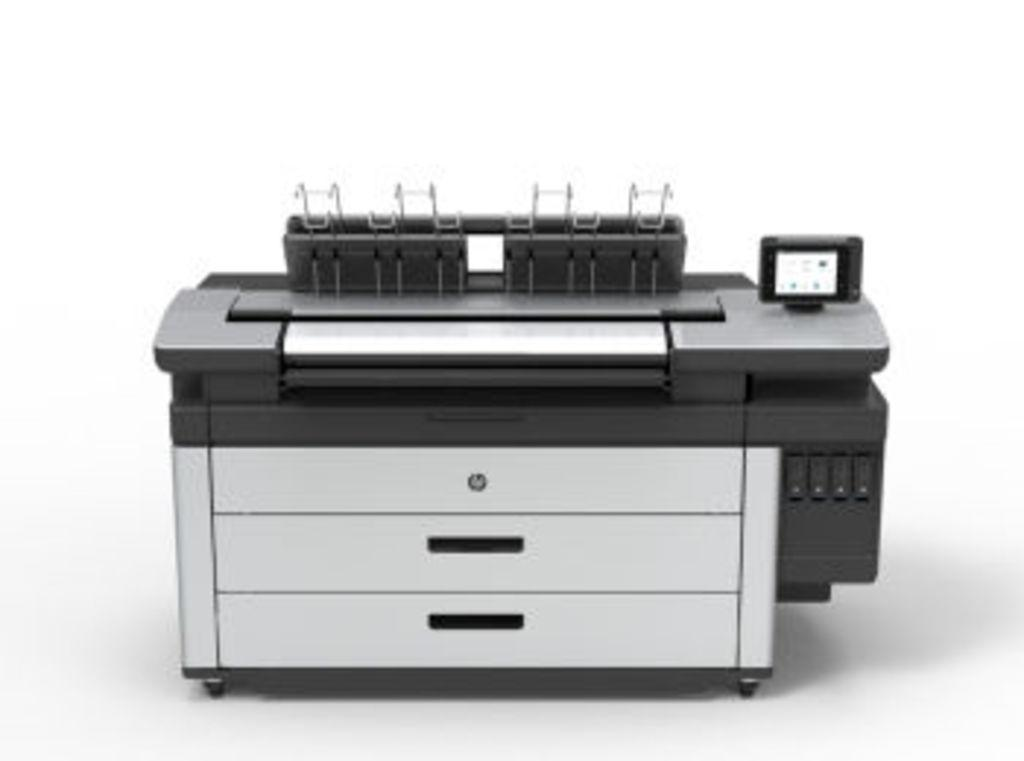What is the main object in the image? There is a printer in the image. What color is the background of the image? The background of the image is white. How much money is being printed by the printer in the image? The printer in the image is not printing money; it is likely printing documents or images. What type of range can be seen in the image? There is no range present in the image; it features a printer and a white background. 